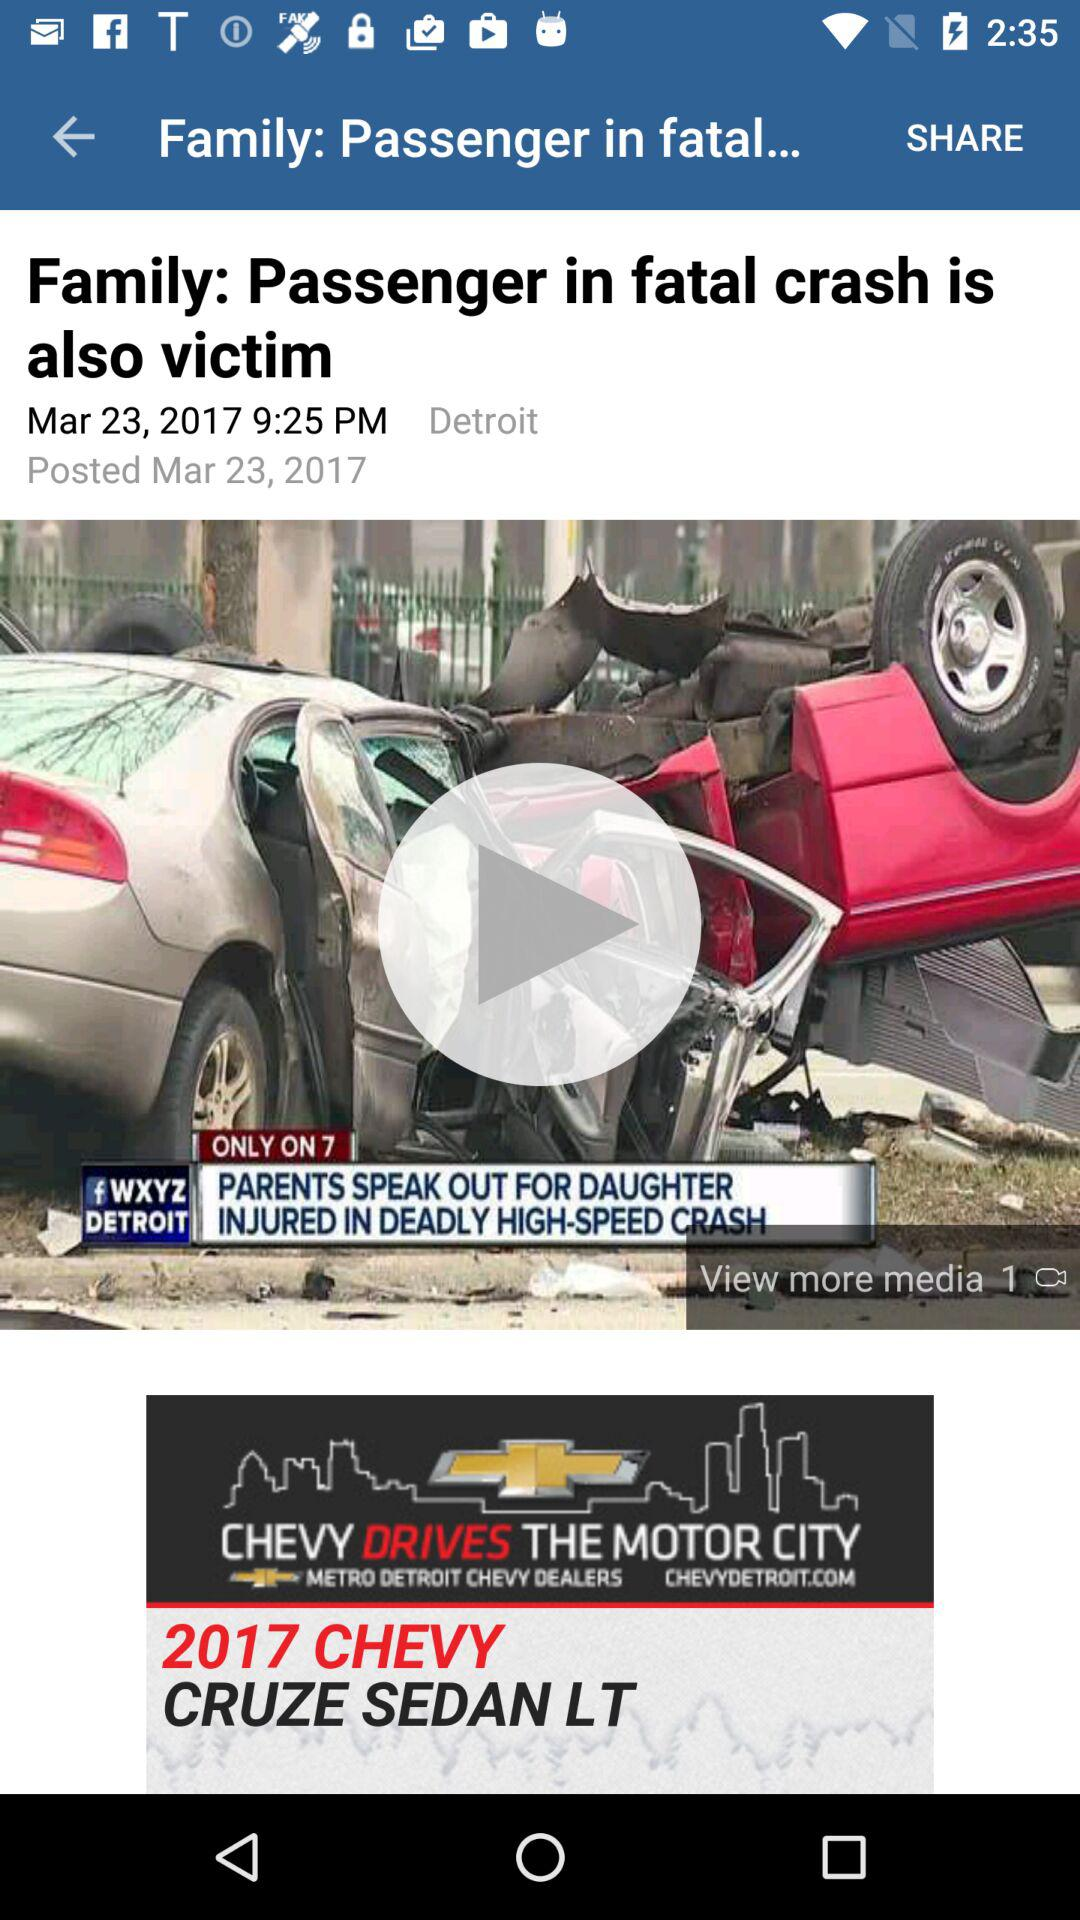On which date was the article published? The article was published on March 23, 2017. 